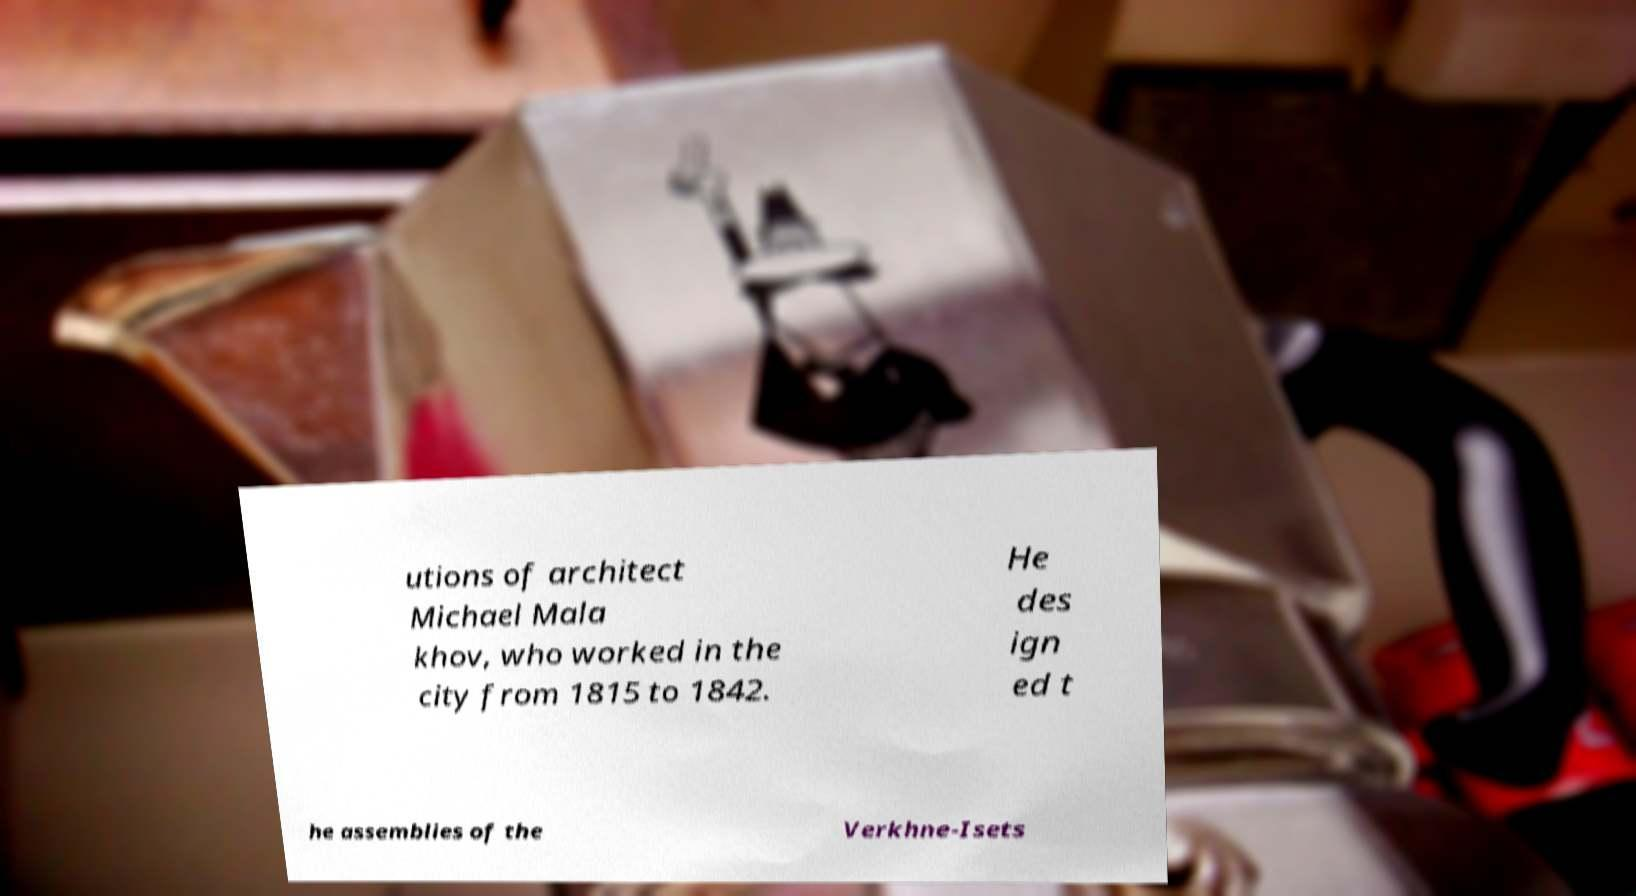Can you accurately transcribe the text from the provided image for me? utions of architect Michael Mala khov, who worked in the city from 1815 to 1842. He des ign ed t he assemblies of the Verkhne-Isets 